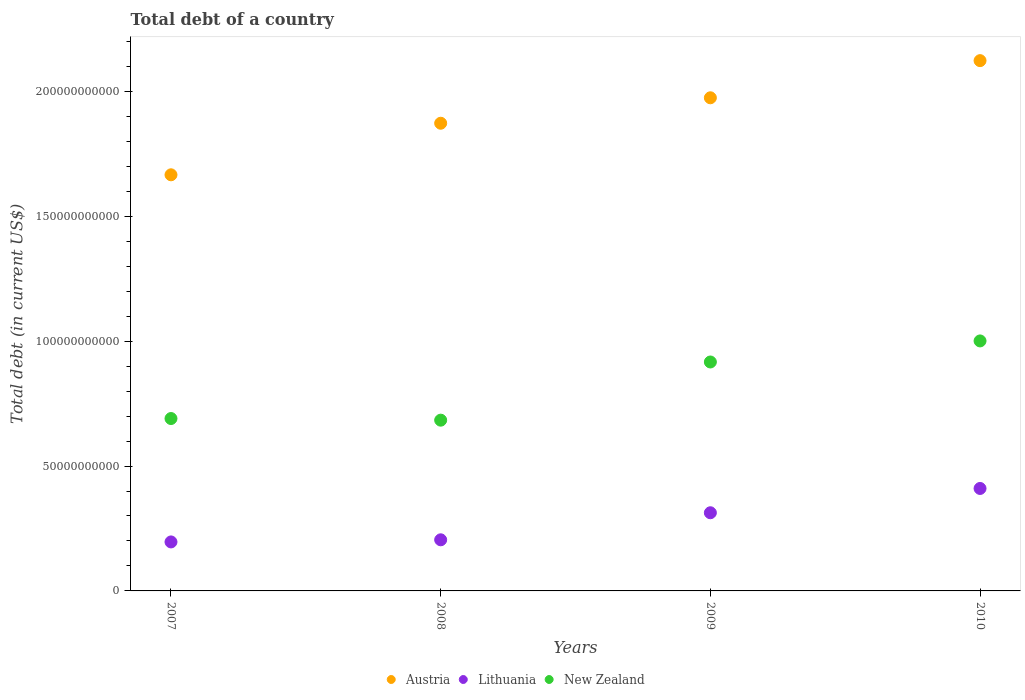What is the debt in New Zealand in 2007?
Your answer should be compact. 6.90e+1. Across all years, what is the maximum debt in New Zealand?
Your answer should be very brief. 1.00e+11. Across all years, what is the minimum debt in New Zealand?
Your answer should be compact. 6.84e+1. In which year was the debt in Austria maximum?
Your answer should be very brief. 2010. In which year was the debt in New Zealand minimum?
Your response must be concise. 2008. What is the total debt in Austria in the graph?
Make the answer very short. 7.64e+11. What is the difference between the debt in Lithuania in 2007 and that in 2009?
Ensure brevity in your answer.  -1.17e+1. What is the difference between the debt in Austria in 2009 and the debt in New Zealand in 2007?
Make the answer very short. 1.28e+11. What is the average debt in Lithuania per year?
Give a very brief answer. 2.81e+1. In the year 2010, what is the difference between the debt in Austria and debt in New Zealand?
Offer a terse response. 1.12e+11. What is the ratio of the debt in New Zealand in 2007 to that in 2008?
Your answer should be very brief. 1.01. Is the difference between the debt in Austria in 2008 and 2010 greater than the difference between the debt in New Zealand in 2008 and 2010?
Provide a succinct answer. Yes. What is the difference between the highest and the second highest debt in New Zealand?
Your answer should be very brief. 8.43e+09. What is the difference between the highest and the lowest debt in Lithuania?
Your answer should be compact. 2.14e+1. In how many years, is the debt in Lithuania greater than the average debt in Lithuania taken over all years?
Your answer should be compact. 2. Is the sum of the debt in New Zealand in 2008 and 2010 greater than the maximum debt in Lithuania across all years?
Ensure brevity in your answer.  Yes. Is it the case that in every year, the sum of the debt in Lithuania and debt in Austria  is greater than the debt in New Zealand?
Offer a very short reply. Yes. Is the debt in Lithuania strictly greater than the debt in New Zealand over the years?
Provide a short and direct response. No. Is the debt in Lithuania strictly less than the debt in Austria over the years?
Offer a very short reply. Yes. What is the difference between two consecutive major ticks on the Y-axis?
Provide a succinct answer. 5.00e+1. Does the graph contain any zero values?
Offer a very short reply. No. Does the graph contain grids?
Offer a very short reply. No. How are the legend labels stacked?
Keep it short and to the point. Horizontal. What is the title of the graph?
Offer a very short reply. Total debt of a country. What is the label or title of the Y-axis?
Your answer should be very brief. Total debt (in current US$). What is the Total debt (in current US$) in Austria in 2007?
Provide a short and direct response. 1.67e+11. What is the Total debt (in current US$) of Lithuania in 2007?
Your response must be concise. 1.96e+1. What is the Total debt (in current US$) in New Zealand in 2007?
Keep it short and to the point. 6.90e+1. What is the Total debt (in current US$) of Austria in 2008?
Your answer should be very brief. 1.87e+11. What is the Total debt (in current US$) in Lithuania in 2008?
Keep it short and to the point. 2.05e+1. What is the Total debt (in current US$) of New Zealand in 2008?
Offer a terse response. 6.84e+1. What is the Total debt (in current US$) of Austria in 2009?
Your answer should be very brief. 1.97e+11. What is the Total debt (in current US$) in Lithuania in 2009?
Ensure brevity in your answer.  3.13e+1. What is the Total debt (in current US$) in New Zealand in 2009?
Make the answer very short. 9.17e+1. What is the Total debt (in current US$) of Austria in 2010?
Make the answer very short. 2.12e+11. What is the Total debt (in current US$) of Lithuania in 2010?
Offer a terse response. 4.10e+1. What is the Total debt (in current US$) in New Zealand in 2010?
Give a very brief answer. 1.00e+11. Across all years, what is the maximum Total debt (in current US$) of Austria?
Your response must be concise. 2.12e+11. Across all years, what is the maximum Total debt (in current US$) in Lithuania?
Provide a short and direct response. 4.10e+1. Across all years, what is the maximum Total debt (in current US$) in New Zealand?
Provide a succinct answer. 1.00e+11. Across all years, what is the minimum Total debt (in current US$) of Austria?
Provide a short and direct response. 1.67e+11. Across all years, what is the minimum Total debt (in current US$) in Lithuania?
Make the answer very short. 1.96e+1. Across all years, what is the minimum Total debt (in current US$) of New Zealand?
Your response must be concise. 6.84e+1. What is the total Total debt (in current US$) in Austria in the graph?
Provide a short and direct response. 7.64e+11. What is the total Total debt (in current US$) in Lithuania in the graph?
Make the answer very short. 1.12e+11. What is the total Total debt (in current US$) of New Zealand in the graph?
Provide a succinct answer. 3.29e+11. What is the difference between the Total debt (in current US$) of Austria in 2007 and that in 2008?
Your answer should be compact. -2.06e+1. What is the difference between the Total debt (in current US$) of Lithuania in 2007 and that in 2008?
Give a very brief answer. -8.50e+08. What is the difference between the Total debt (in current US$) in New Zealand in 2007 and that in 2008?
Your response must be concise. 6.55e+08. What is the difference between the Total debt (in current US$) of Austria in 2007 and that in 2009?
Ensure brevity in your answer.  -3.08e+1. What is the difference between the Total debt (in current US$) of Lithuania in 2007 and that in 2009?
Your answer should be compact. -1.17e+1. What is the difference between the Total debt (in current US$) in New Zealand in 2007 and that in 2009?
Provide a succinct answer. -2.26e+1. What is the difference between the Total debt (in current US$) of Austria in 2007 and that in 2010?
Make the answer very short. -4.57e+1. What is the difference between the Total debt (in current US$) in Lithuania in 2007 and that in 2010?
Provide a short and direct response. -2.14e+1. What is the difference between the Total debt (in current US$) of New Zealand in 2007 and that in 2010?
Your response must be concise. -3.11e+1. What is the difference between the Total debt (in current US$) of Austria in 2008 and that in 2009?
Offer a terse response. -1.02e+1. What is the difference between the Total debt (in current US$) of Lithuania in 2008 and that in 2009?
Your response must be concise. -1.08e+1. What is the difference between the Total debt (in current US$) in New Zealand in 2008 and that in 2009?
Make the answer very short. -2.33e+1. What is the difference between the Total debt (in current US$) of Austria in 2008 and that in 2010?
Offer a very short reply. -2.51e+1. What is the difference between the Total debt (in current US$) in Lithuania in 2008 and that in 2010?
Keep it short and to the point. -2.06e+1. What is the difference between the Total debt (in current US$) in New Zealand in 2008 and that in 2010?
Make the answer very short. -3.17e+1. What is the difference between the Total debt (in current US$) in Austria in 2009 and that in 2010?
Keep it short and to the point. -1.49e+1. What is the difference between the Total debt (in current US$) of Lithuania in 2009 and that in 2010?
Your answer should be very brief. -9.73e+09. What is the difference between the Total debt (in current US$) in New Zealand in 2009 and that in 2010?
Provide a succinct answer. -8.43e+09. What is the difference between the Total debt (in current US$) of Austria in 2007 and the Total debt (in current US$) of Lithuania in 2008?
Ensure brevity in your answer.  1.46e+11. What is the difference between the Total debt (in current US$) of Austria in 2007 and the Total debt (in current US$) of New Zealand in 2008?
Keep it short and to the point. 9.82e+1. What is the difference between the Total debt (in current US$) in Lithuania in 2007 and the Total debt (in current US$) in New Zealand in 2008?
Provide a succinct answer. -4.88e+1. What is the difference between the Total debt (in current US$) of Austria in 2007 and the Total debt (in current US$) of Lithuania in 2009?
Give a very brief answer. 1.35e+11. What is the difference between the Total debt (in current US$) of Austria in 2007 and the Total debt (in current US$) of New Zealand in 2009?
Your answer should be very brief. 7.49e+1. What is the difference between the Total debt (in current US$) of Lithuania in 2007 and the Total debt (in current US$) of New Zealand in 2009?
Make the answer very short. -7.20e+1. What is the difference between the Total debt (in current US$) in Austria in 2007 and the Total debt (in current US$) in Lithuania in 2010?
Provide a succinct answer. 1.26e+11. What is the difference between the Total debt (in current US$) in Austria in 2007 and the Total debt (in current US$) in New Zealand in 2010?
Provide a succinct answer. 6.65e+1. What is the difference between the Total debt (in current US$) in Lithuania in 2007 and the Total debt (in current US$) in New Zealand in 2010?
Your answer should be very brief. -8.05e+1. What is the difference between the Total debt (in current US$) in Austria in 2008 and the Total debt (in current US$) in Lithuania in 2009?
Offer a very short reply. 1.56e+11. What is the difference between the Total debt (in current US$) of Austria in 2008 and the Total debt (in current US$) of New Zealand in 2009?
Your answer should be compact. 9.56e+1. What is the difference between the Total debt (in current US$) in Lithuania in 2008 and the Total debt (in current US$) in New Zealand in 2009?
Provide a succinct answer. -7.12e+1. What is the difference between the Total debt (in current US$) in Austria in 2008 and the Total debt (in current US$) in Lithuania in 2010?
Your answer should be very brief. 1.46e+11. What is the difference between the Total debt (in current US$) in Austria in 2008 and the Total debt (in current US$) in New Zealand in 2010?
Keep it short and to the point. 8.72e+1. What is the difference between the Total debt (in current US$) in Lithuania in 2008 and the Total debt (in current US$) in New Zealand in 2010?
Your answer should be very brief. -7.96e+1. What is the difference between the Total debt (in current US$) of Austria in 2009 and the Total debt (in current US$) of Lithuania in 2010?
Provide a short and direct response. 1.56e+11. What is the difference between the Total debt (in current US$) in Austria in 2009 and the Total debt (in current US$) in New Zealand in 2010?
Keep it short and to the point. 9.74e+1. What is the difference between the Total debt (in current US$) in Lithuania in 2009 and the Total debt (in current US$) in New Zealand in 2010?
Keep it short and to the point. -6.88e+1. What is the average Total debt (in current US$) in Austria per year?
Your response must be concise. 1.91e+11. What is the average Total debt (in current US$) in Lithuania per year?
Give a very brief answer. 2.81e+1. What is the average Total debt (in current US$) of New Zealand per year?
Ensure brevity in your answer.  8.23e+1. In the year 2007, what is the difference between the Total debt (in current US$) of Austria and Total debt (in current US$) of Lithuania?
Your answer should be very brief. 1.47e+11. In the year 2007, what is the difference between the Total debt (in current US$) in Austria and Total debt (in current US$) in New Zealand?
Your response must be concise. 9.76e+1. In the year 2007, what is the difference between the Total debt (in current US$) of Lithuania and Total debt (in current US$) of New Zealand?
Ensure brevity in your answer.  -4.94e+1. In the year 2008, what is the difference between the Total debt (in current US$) in Austria and Total debt (in current US$) in Lithuania?
Your response must be concise. 1.67e+11. In the year 2008, what is the difference between the Total debt (in current US$) in Austria and Total debt (in current US$) in New Zealand?
Your response must be concise. 1.19e+11. In the year 2008, what is the difference between the Total debt (in current US$) of Lithuania and Total debt (in current US$) of New Zealand?
Offer a very short reply. -4.79e+1. In the year 2009, what is the difference between the Total debt (in current US$) of Austria and Total debt (in current US$) of Lithuania?
Your answer should be compact. 1.66e+11. In the year 2009, what is the difference between the Total debt (in current US$) of Austria and Total debt (in current US$) of New Zealand?
Make the answer very short. 1.06e+11. In the year 2009, what is the difference between the Total debt (in current US$) in Lithuania and Total debt (in current US$) in New Zealand?
Your answer should be compact. -6.04e+1. In the year 2010, what is the difference between the Total debt (in current US$) of Austria and Total debt (in current US$) of Lithuania?
Your answer should be very brief. 1.71e+11. In the year 2010, what is the difference between the Total debt (in current US$) in Austria and Total debt (in current US$) in New Zealand?
Offer a terse response. 1.12e+11. In the year 2010, what is the difference between the Total debt (in current US$) of Lithuania and Total debt (in current US$) of New Zealand?
Your answer should be very brief. -5.91e+1. What is the ratio of the Total debt (in current US$) of Austria in 2007 to that in 2008?
Your response must be concise. 0.89. What is the ratio of the Total debt (in current US$) of Lithuania in 2007 to that in 2008?
Ensure brevity in your answer.  0.96. What is the ratio of the Total debt (in current US$) of New Zealand in 2007 to that in 2008?
Offer a terse response. 1.01. What is the ratio of the Total debt (in current US$) in Austria in 2007 to that in 2009?
Give a very brief answer. 0.84. What is the ratio of the Total debt (in current US$) of Lithuania in 2007 to that in 2009?
Give a very brief answer. 0.63. What is the ratio of the Total debt (in current US$) in New Zealand in 2007 to that in 2009?
Your answer should be compact. 0.75. What is the ratio of the Total debt (in current US$) in Austria in 2007 to that in 2010?
Offer a very short reply. 0.78. What is the ratio of the Total debt (in current US$) of Lithuania in 2007 to that in 2010?
Keep it short and to the point. 0.48. What is the ratio of the Total debt (in current US$) in New Zealand in 2007 to that in 2010?
Ensure brevity in your answer.  0.69. What is the ratio of the Total debt (in current US$) in Austria in 2008 to that in 2009?
Offer a terse response. 0.95. What is the ratio of the Total debt (in current US$) of Lithuania in 2008 to that in 2009?
Make the answer very short. 0.65. What is the ratio of the Total debt (in current US$) of New Zealand in 2008 to that in 2009?
Provide a succinct answer. 0.75. What is the ratio of the Total debt (in current US$) in Austria in 2008 to that in 2010?
Keep it short and to the point. 0.88. What is the ratio of the Total debt (in current US$) of Lithuania in 2008 to that in 2010?
Provide a succinct answer. 0.5. What is the ratio of the Total debt (in current US$) in New Zealand in 2008 to that in 2010?
Provide a succinct answer. 0.68. What is the ratio of the Total debt (in current US$) in Austria in 2009 to that in 2010?
Offer a terse response. 0.93. What is the ratio of the Total debt (in current US$) of Lithuania in 2009 to that in 2010?
Give a very brief answer. 0.76. What is the ratio of the Total debt (in current US$) of New Zealand in 2009 to that in 2010?
Offer a terse response. 0.92. What is the difference between the highest and the second highest Total debt (in current US$) in Austria?
Ensure brevity in your answer.  1.49e+1. What is the difference between the highest and the second highest Total debt (in current US$) of Lithuania?
Provide a succinct answer. 9.73e+09. What is the difference between the highest and the second highest Total debt (in current US$) in New Zealand?
Offer a terse response. 8.43e+09. What is the difference between the highest and the lowest Total debt (in current US$) of Austria?
Ensure brevity in your answer.  4.57e+1. What is the difference between the highest and the lowest Total debt (in current US$) of Lithuania?
Provide a succinct answer. 2.14e+1. What is the difference between the highest and the lowest Total debt (in current US$) of New Zealand?
Your answer should be compact. 3.17e+1. 